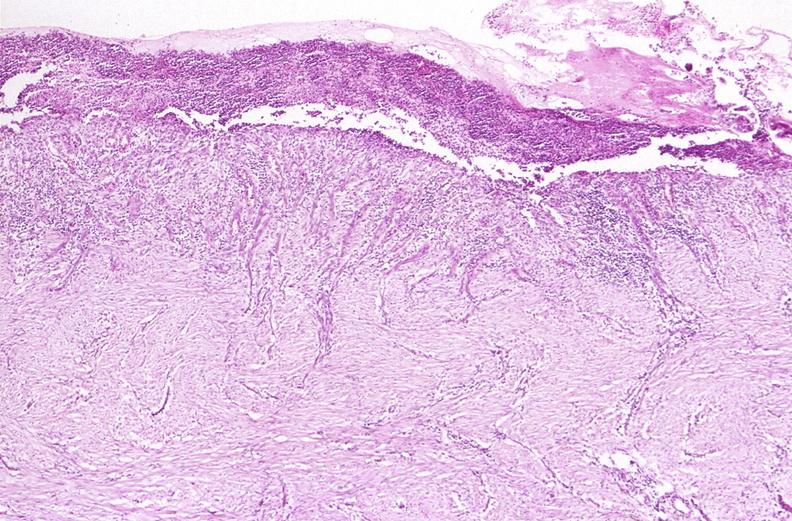what does this image show?
Answer the question using a single word or phrase. Stomach 